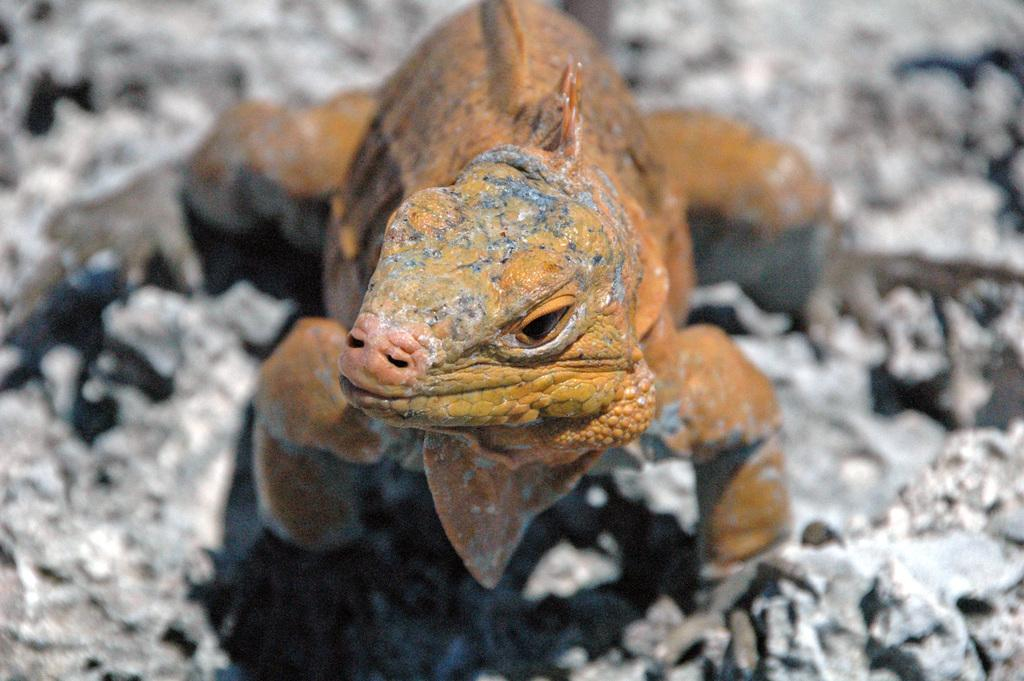What type of animal is present in the image? There is a reptile in the image. Where is the reptile located? The reptile is on a rock. What type of garden can be seen in the image? There is no garden present in the image; it features a reptile on a rock. What type of loss is depicted in the image? There is no loss depicted in the image; it features a reptile on a rock. 